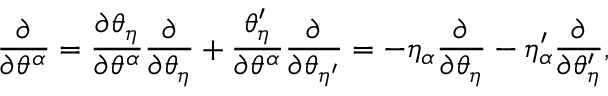Convert formula to latex. <formula><loc_0><loc_0><loc_500><loc_500>\frac { \partial } { \partial \theta ^ { \alpha } } = \frac { \partial \theta _ { \eta } } { \partial \theta ^ { \alpha } } \frac { \partial } { \partial \theta _ { \eta } } + \frac { \theta _ { \eta } ^ { \prime } } { \partial \theta ^ { \alpha } } \frac { \partial } { \partial \theta _ { \eta ^ { \prime } } } = - \eta _ { \alpha } \frac { \partial } { \partial \theta _ { \eta } } - \eta _ { \alpha } ^ { \prime } \frac { \partial } { \partial \theta _ { \eta } ^ { \prime } } ,</formula> 